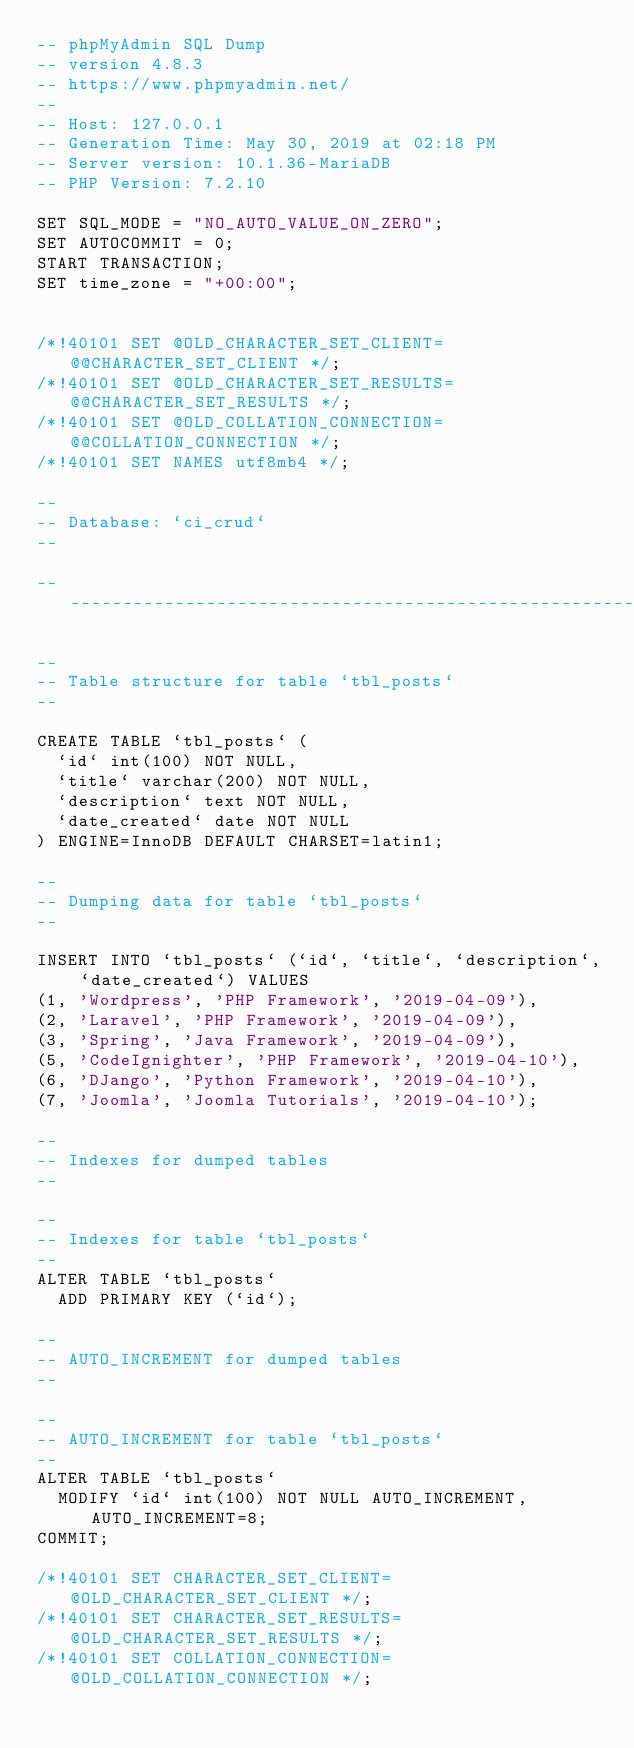<code> <loc_0><loc_0><loc_500><loc_500><_SQL_>-- phpMyAdmin SQL Dump
-- version 4.8.3
-- https://www.phpmyadmin.net/
--
-- Host: 127.0.0.1
-- Generation Time: May 30, 2019 at 02:18 PM
-- Server version: 10.1.36-MariaDB
-- PHP Version: 7.2.10

SET SQL_MODE = "NO_AUTO_VALUE_ON_ZERO";
SET AUTOCOMMIT = 0;
START TRANSACTION;
SET time_zone = "+00:00";


/*!40101 SET @OLD_CHARACTER_SET_CLIENT=@@CHARACTER_SET_CLIENT */;
/*!40101 SET @OLD_CHARACTER_SET_RESULTS=@@CHARACTER_SET_RESULTS */;
/*!40101 SET @OLD_COLLATION_CONNECTION=@@COLLATION_CONNECTION */;
/*!40101 SET NAMES utf8mb4 */;

--
-- Database: `ci_crud`
--

-- --------------------------------------------------------

--
-- Table structure for table `tbl_posts`
--

CREATE TABLE `tbl_posts` (
  `id` int(100) NOT NULL,
  `title` varchar(200) NOT NULL,
  `description` text NOT NULL,
  `date_created` date NOT NULL
) ENGINE=InnoDB DEFAULT CHARSET=latin1;

--
-- Dumping data for table `tbl_posts`
--

INSERT INTO `tbl_posts` (`id`, `title`, `description`, `date_created`) VALUES
(1, 'Wordpress', 'PHP Framework', '2019-04-09'),
(2, 'Laravel', 'PHP Framework', '2019-04-09'),
(3, 'Spring', 'Java Framework', '2019-04-09'),
(5, 'CodeIgnighter', 'PHP Framework', '2019-04-10'),
(6, 'DJango', 'Python Framework', '2019-04-10'),
(7, 'Joomla', 'Joomla Tutorials', '2019-04-10');

--
-- Indexes for dumped tables
--

--
-- Indexes for table `tbl_posts`
--
ALTER TABLE `tbl_posts`
  ADD PRIMARY KEY (`id`);

--
-- AUTO_INCREMENT for dumped tables
--

--
-- AUTO_INCREMENT for table `tbl_posts`
--
ALTER TABLE `tbl_posts`
  MODIFY `id` int(100) NOT NULL AUTO_INCREMENT, AUTO_INCREMENT=8;
COMMIT;

/*!40101 SET CHARACTER_SET_CLIENT=@OLD_CHARACTER_SET_CLIENT */;
/*!40101 SET CHARACTER_SET_RESULTS=@OLD_CHARACTER_SET_RESULTS */;
/*!40101 SET COLLATION_CONNECTION=@OLD_COLLATION_CONNECTION */;
</code> 